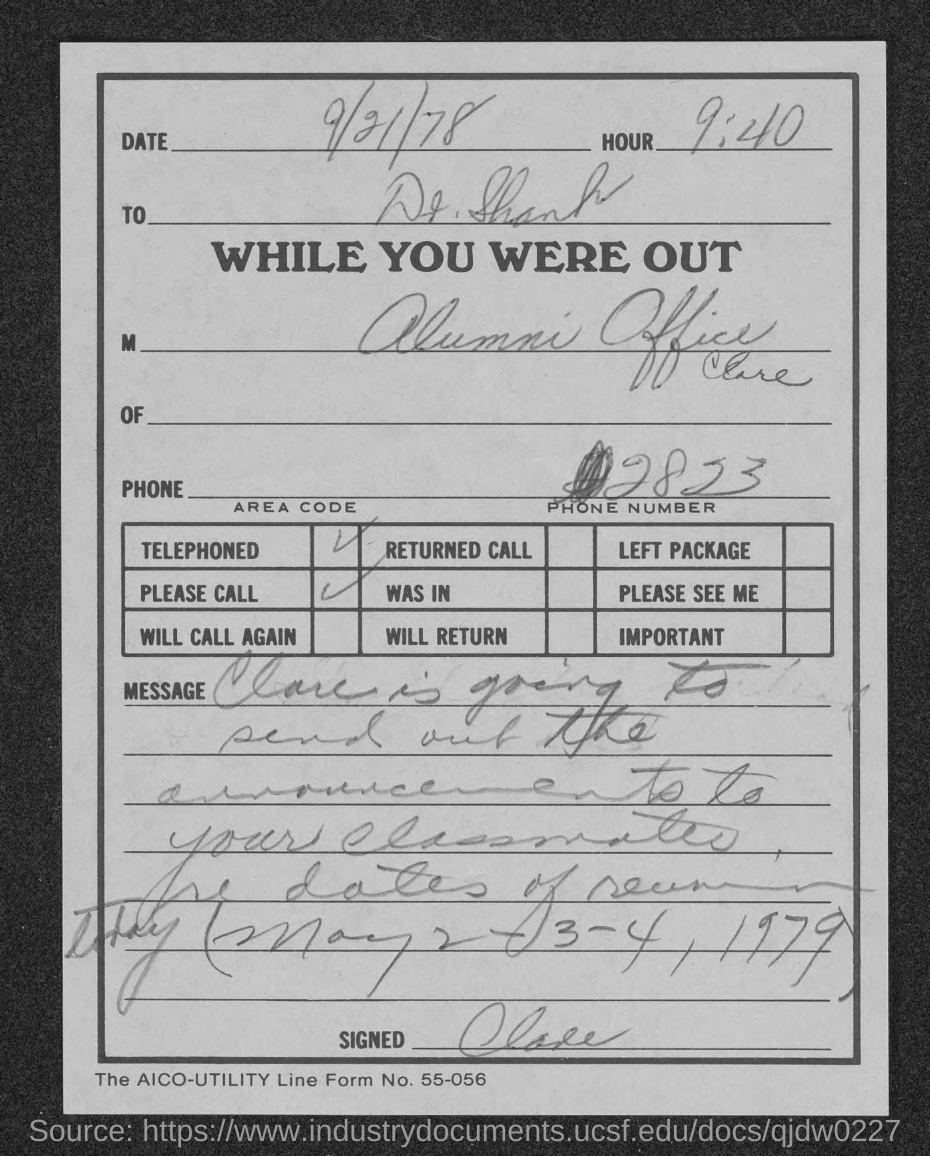Draw attention to some important aspects in this diagram. What is the AICO-UTILITY line form number? It is 55-056... 